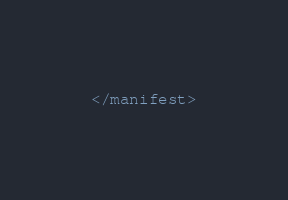Convert code to text. <code><loc_0><loc_0><loc_500><loc_500><_XML_></manifest>
</code> 